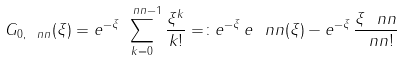<formula> <loc_0><loc_0><loc_500><loc_500>G _ { 0 , \ n n } ( \xi ) = { e } ^ { - \xi } \sum _ { k = 0 } ^ { \ n n - 1 } \frac { \xi ^ { k } } { k ! } = \colon { e } ^ { - \xi } \, { e } _ { \ } n n ( \xi ) - { e } ^ { - \xi } \, \frac { \xi ^ { \ } n n } { \ n n ! }</formula> 